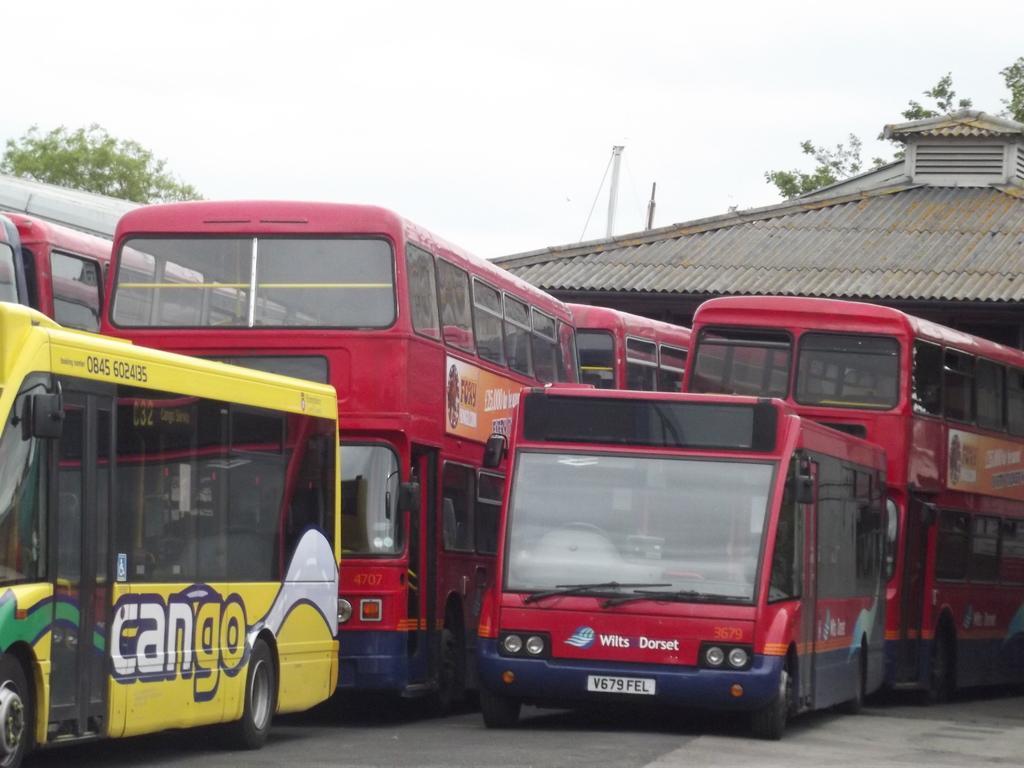Could you give a brief overview of what you see in this image? In this picture there are buses and there is text on the buses. At the back there is a building and there are trees and poles. At the top there is sky. At the bottom there is a road. 